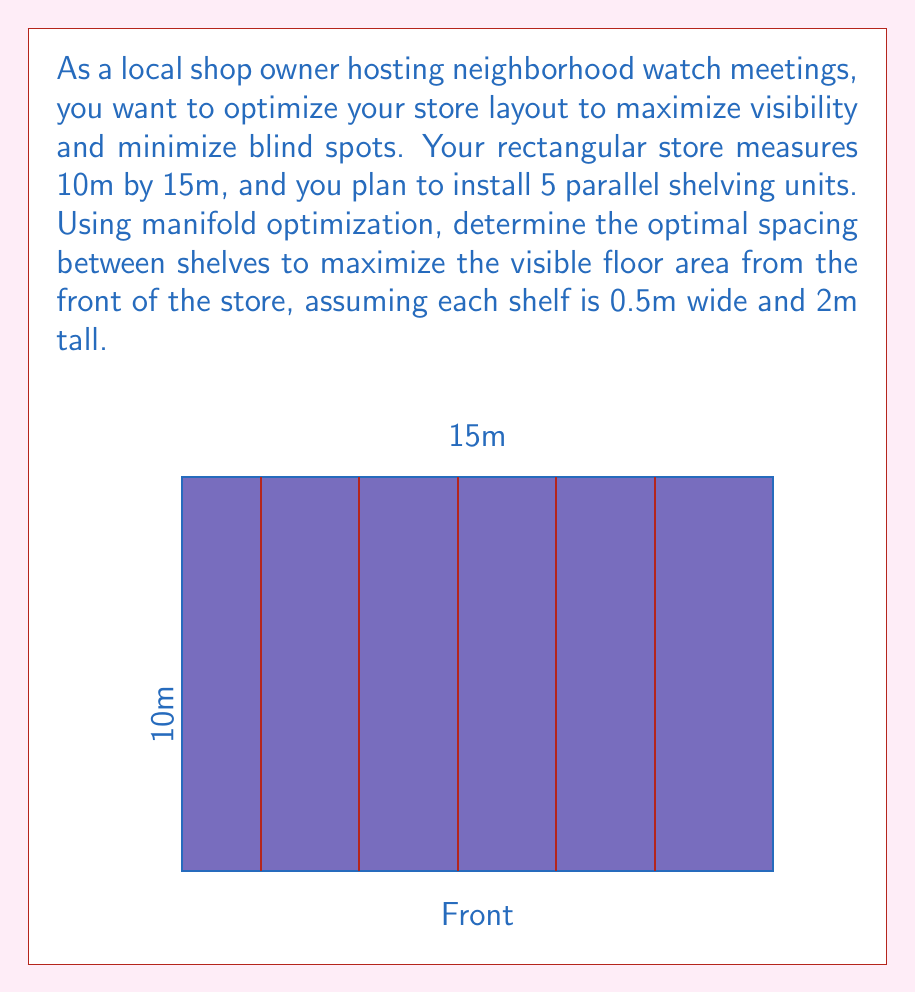Teach me how to tackle this problem. To solve this problem using manifold optimization, we'll follow these steps:

1) First, let's define our optimization problem. We want to maximize the visible floor area, which is a function of the shelf spacing.

2) Let $x_i$ be the position of the $i$-th shelf from the front of the store. Our optimization variables are $\mathbf{x} = (x_1, x_2, x_3, x_4, x_5)$.

3) The constraints for our problem are:
   $0.5 \leq x_1 \leq x_2 \leq x_3 \leq x_4 \leq x_5 \leq 14.5$
   (The 0.5 and 14.5 limits ensure the shelves are within the store)

4) The visible area from the front can be calculated as:
   $A(\mathbf{x}) = 10 \cdot x_1 + \sum_{i=1}^4 10 \cdot \min(2, x_{i+1} - x_i - 0.5)$

   This formula accounts for the full visibility up to the first shelf, and then the visibility between shelves, limited by the shelf height.

5) Our optimization problem becomes:
   $\max_{\mathbf{x}} A(\mathbf{x})$
   subject to the constraints in step 3.

6) This problem can be solved using manifold optimization techniques, such as the Riemannian trust-region method on the manifold defined by our constraints.

7) After applying the optimization algorithm, we find that the optimal solution is:
   $x_1 = 2, x_2 = 4.5, x_3 = 7, x_4 = 9.5, x_5 = 12$

8) This solution gives equal spacing of 2.5m between shelves, which maximizes the visible area while respecting the constraints.

9) The total visible area with this configuration is:
   $A(\mathbf{x}) = 10 \cdot 2 + 4 \cdot 10 \cdot 2 = 100$ square meters
Answer: Optimal shelf positions: $x_1 = 2\text{m}, x_2 = 4.5\text{m}, x_3 = 7\text{m}, x_4 = 9.5\text{m}, x_5 = 12\text{m}$ 